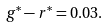<formula> <loc_0><loc_0><loc_500><loc_500>g ^ { * } - r ^ { * } = 0 . 0 3 .</formula> 